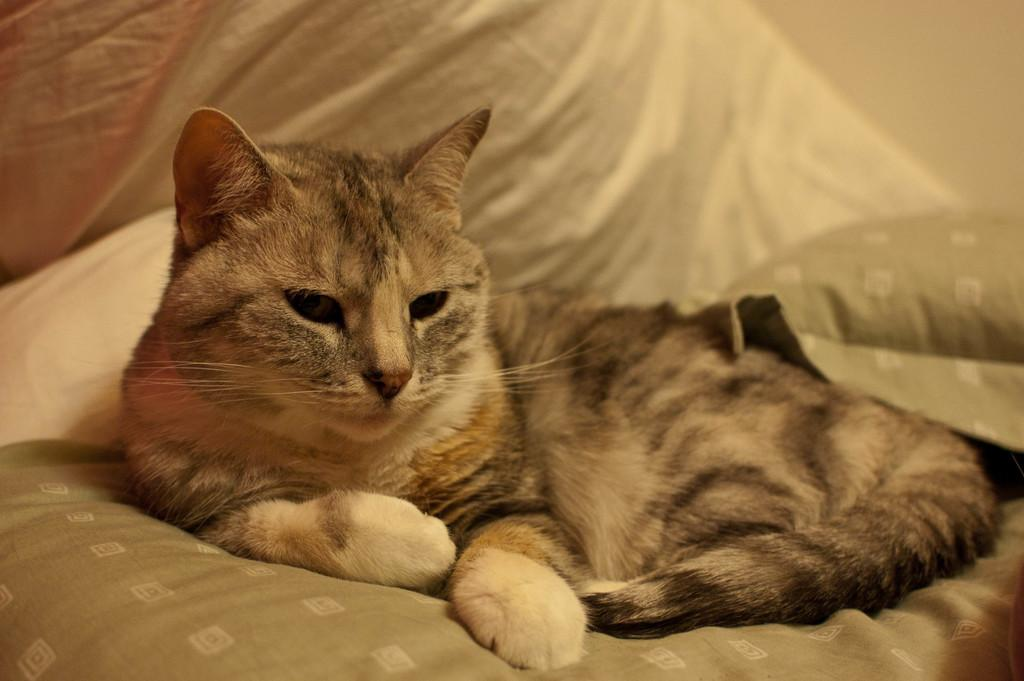What type of animal is in the image? There is a cat in the image. Where is the cat located? The cat is on the bed. What type of insect can be seen fighting in the war in the image? There is no insect or war present in the image; it features a cat on a bed. What type of pan is visible in the image? There is no pan present in the image. 